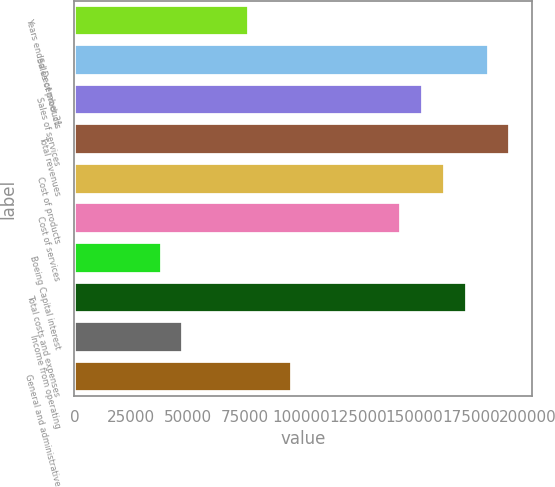<chart> <loc_0><loc_0><loc_500><loc_500><bar_chart><fcel>Years ended December 31<fcel>Sales of products<fcel>Sales of services<fcel>Total revenues<fcel>Cost of products<fcel>Cost of services<fcel>Boeing Capital interest<fcel>Total costs and expenses<fcel>Income from operating<fcel>General and administrative<nl><fcel>76891.4<fcel>182616<fcel>153782<fcel>192227<fcel>163393<fcel>144170<fcel>38446.2<fcel>173004<fcel>48057.5<fcel>96114<nl></chart> 